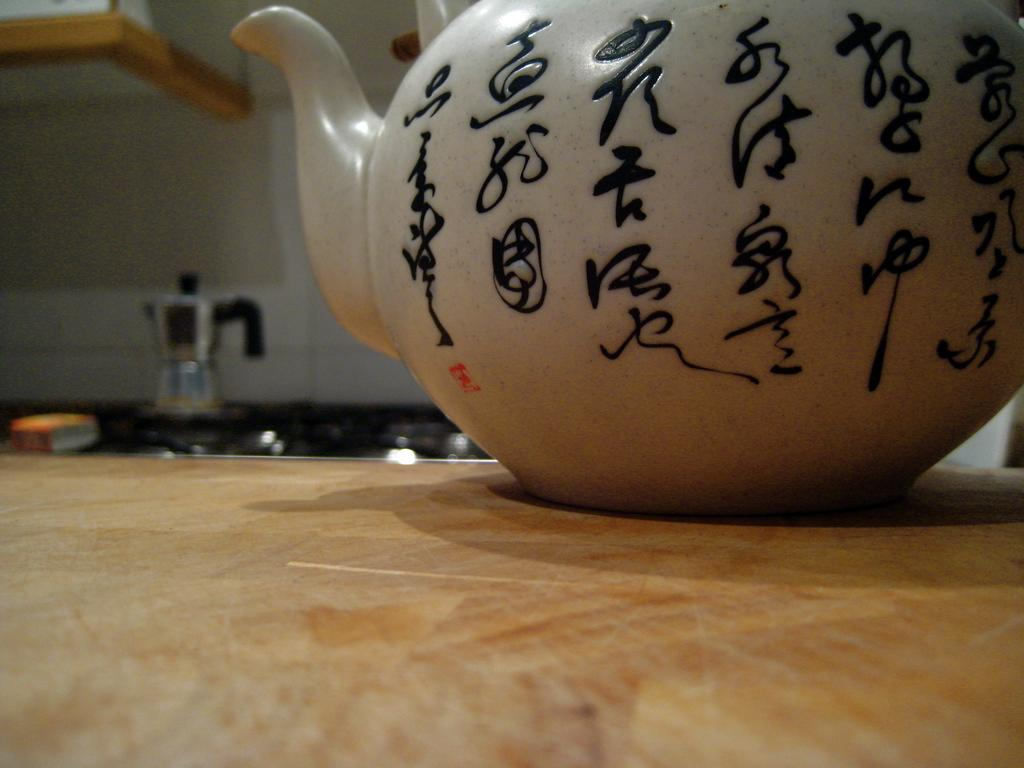What is the color of the wall in the image? The wall in the image is white. What appliance can be seen in the image? There is a mixer in the image. What piece of furniture is present in the image? There is a table in the image. What is on top of the table in the image? There is a tea pot on the table. Can you hear any thunder in the image? There is no sound or indication of thunder in the image, as it is a still image. 